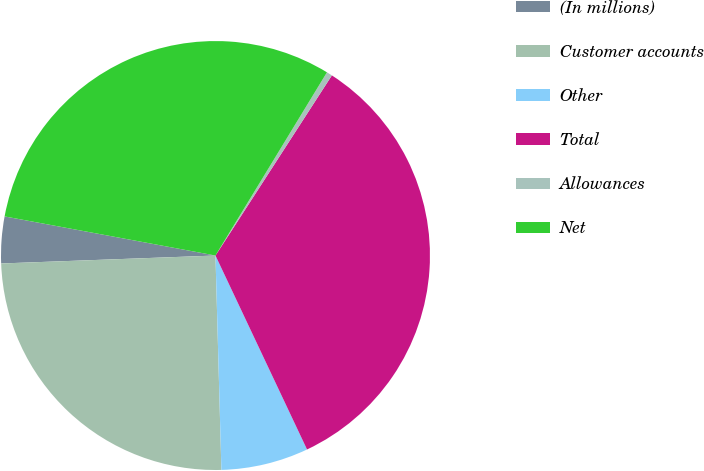Convert chart. <chart><loc_0><loc_0><loc_500><loc_500><pie_chart><fcel>(In millions)<fcel>Customer accounts<fcel>Other<fcel>Total<fcel>Allowances<fcel>Net<nl><fcel>3.51%<fcel>24.85%<fcel>6.58%<fcel>33.85%<fcel>0.43%<fcel>30.78%<nl></chart> 